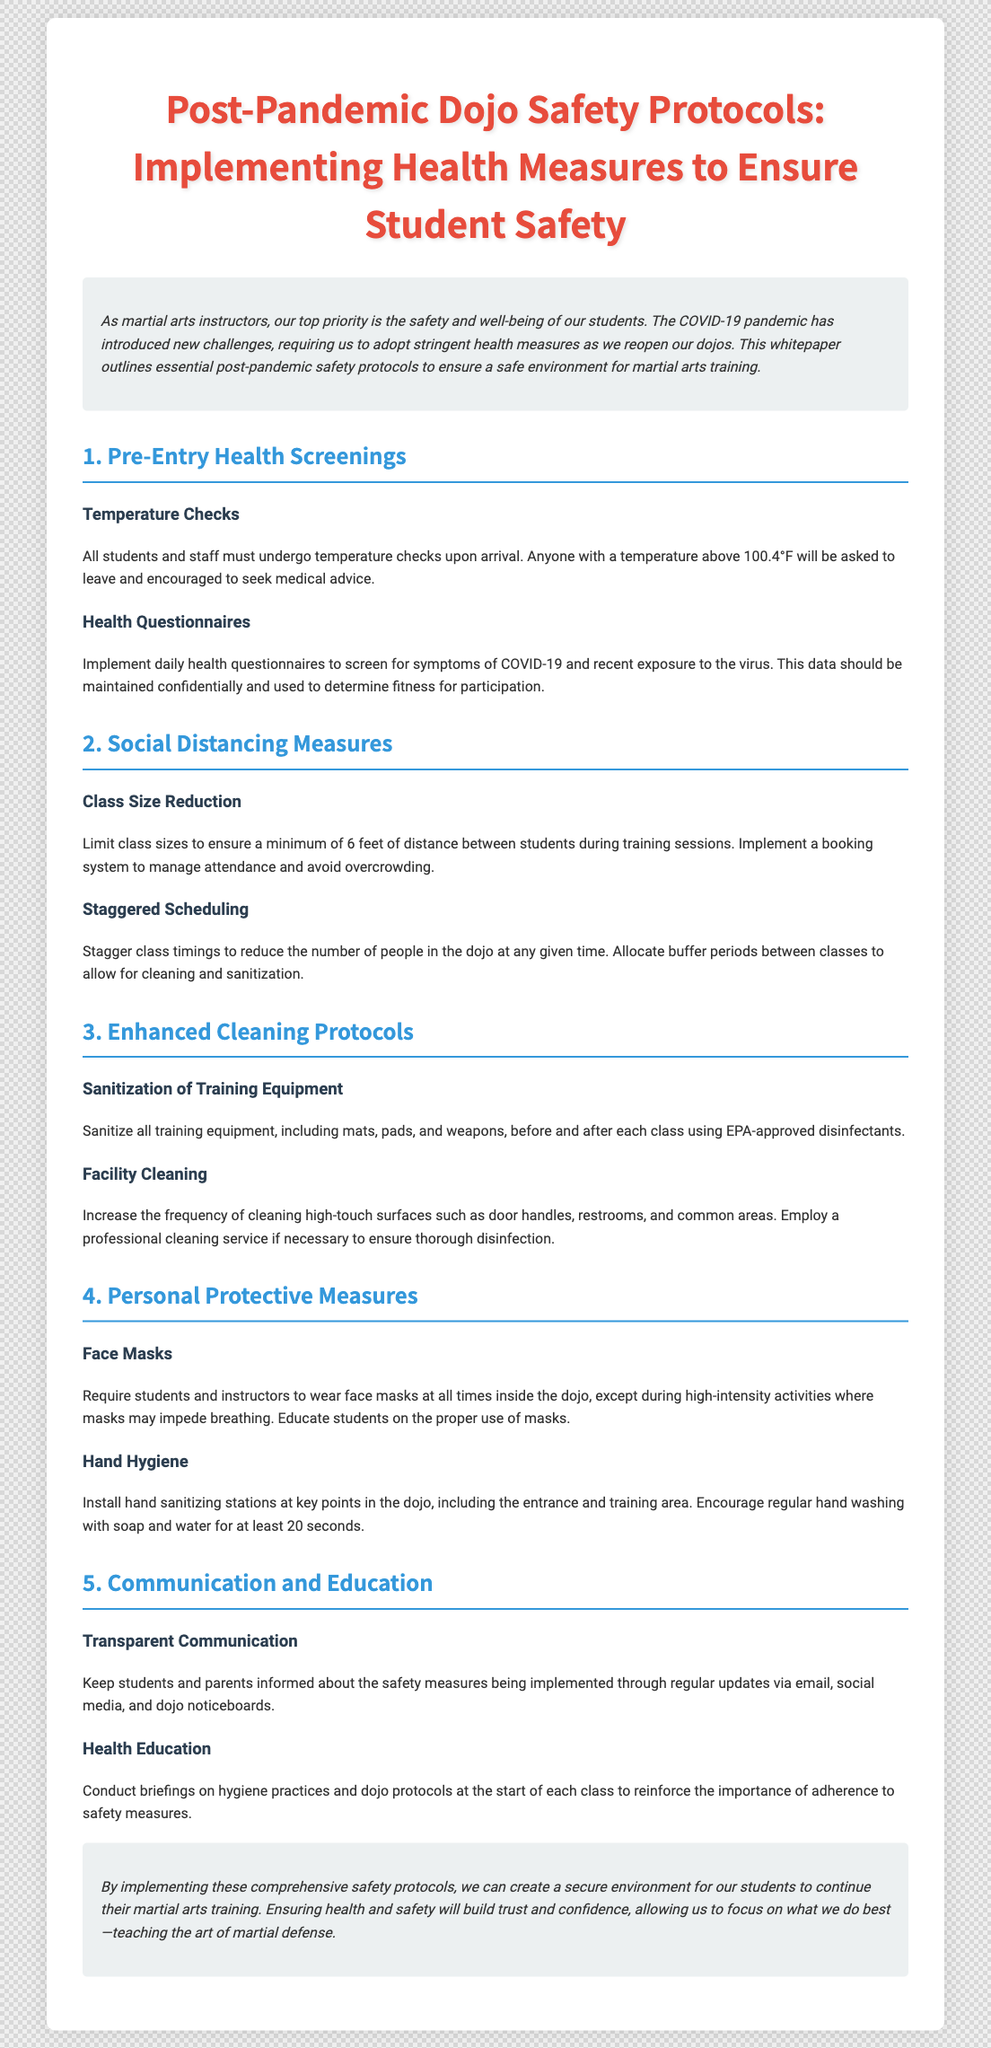What temperature indicates a person should leave the dojo? The document states that anyone with a temperature above 100.4°F will be asked to leave.
Answer: 100.4°F What minimum distance should be maintained between students? The document specifies a minimum of 6 feet of distance between students during training sessions.
Answer: 6 feet What should be installed at key points in the dojo? The document recommends installing hand sanitizing stations at key points.
Answer: Hand sanitizing stations What is the primary purpose of implementing health measures? The document emphasizes that the top priority is the safety and well-being of students.
Answer: Safety and well-being How often should high-touch surfaces be cleaned? The document indicates to increase the frequency of cleaning high-touch surfaces.
Answer: Increase frequency What protocol should be conducted at the start of each class? The document suggests conducting briefings on hygiene practices and dojo protocols.
Answer: Briefings What is necessary for all students and instructors to wear? The document requires students and instructors to wear face masks at all times inside the dojo.
Answer: Face masks What type of communication is encouraged with students and parents? The document encourages transparent communication about the safety measures being implemented.
Answer: Transparent communication 